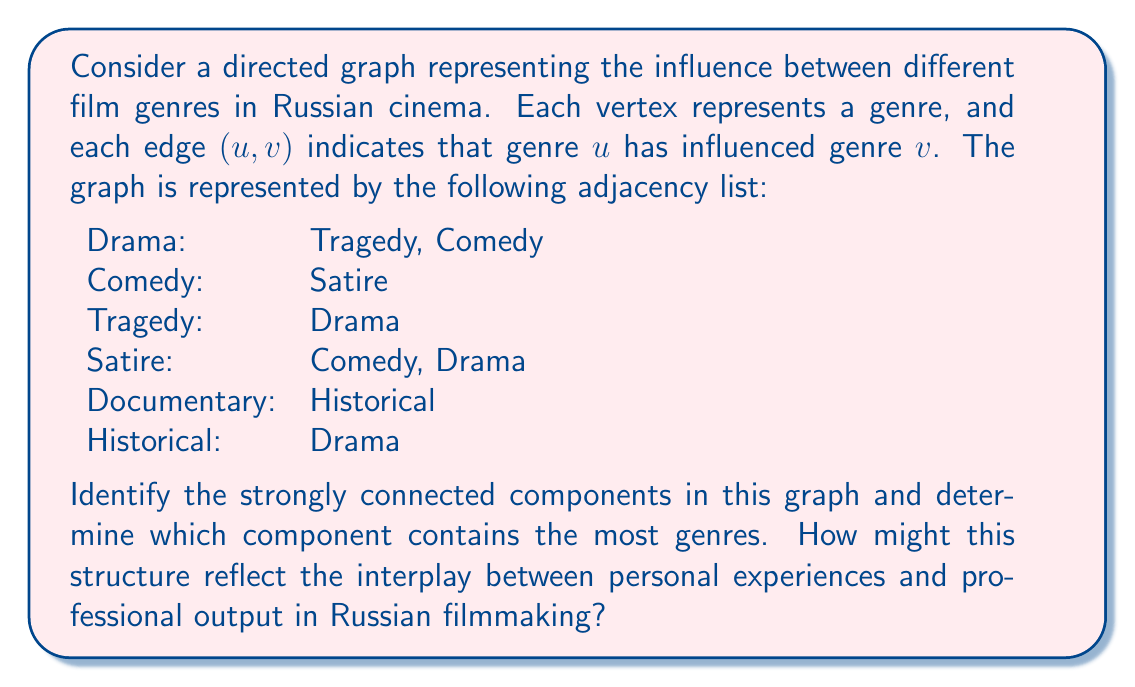Can you solve this math problem? To solve this problem, we'll use Kosaraju's algorithm to find strongly connected components (SCCs) in the directed graph. The algorithm consists of two depth-first search (DFS) passes:

1. Perform DFS on the original graph and store the vertices in a stack based on their finish times.
2. Reverse the graph and perform DFS on the reversed graph, starting with vertices from the top of the stack.

Step 1: DFS on original graph
- Visit order: Drama → Tragedy → Comedy → Satire → Documentary → Historical
- Stack (top to bottom): Historical, Documentary, Satire, Comedy, Tragedy, Drama

Step 2: Reverse the graph
Reversed adjacency list:
Tragedy: Drama
Comedy: Drama, Satire
Satire: Comedy
Drama: Tragedy, Satire
Historical: Documentary
Drama: Historical

Step 3: DFS on reversed graph
- Start with Historical: SCC1 = {Historical}
- Start with Documentary: SCC2 = {Documentary}
- Start with Satire: SCC3 = {Satire, Comedy, Drama, Tragedy}

The strongly connected components are:
1. {Historical}
2. {Documentary}
3. {Satire, Comedy, Drama, Tragedy}

The largest SCC contains 4 genres: Satire, Comedy, Drama, and Tragedy.

This structure reflects the interplay between personal experiences and professional output in Russian filmmaking by showing how closely related genres influence each other. The largest SCC suggests that Satire, Comedy, Drama, and Tragedy are deeply interconnected in Russian cinema, potentially indicating that filmmakers' personal experiences in these genres significantly impact their work across all four. The isolation of Documentary and Historical genres might suggest that these are more specialized areas with less direct influence on or from the other genres.
Answer: The graph contains 3 strongly connected components: {Historical}, {Documentary}, and {Satire, Comedy, Drama, Tragedy}. The largest component contains 4 genres. 